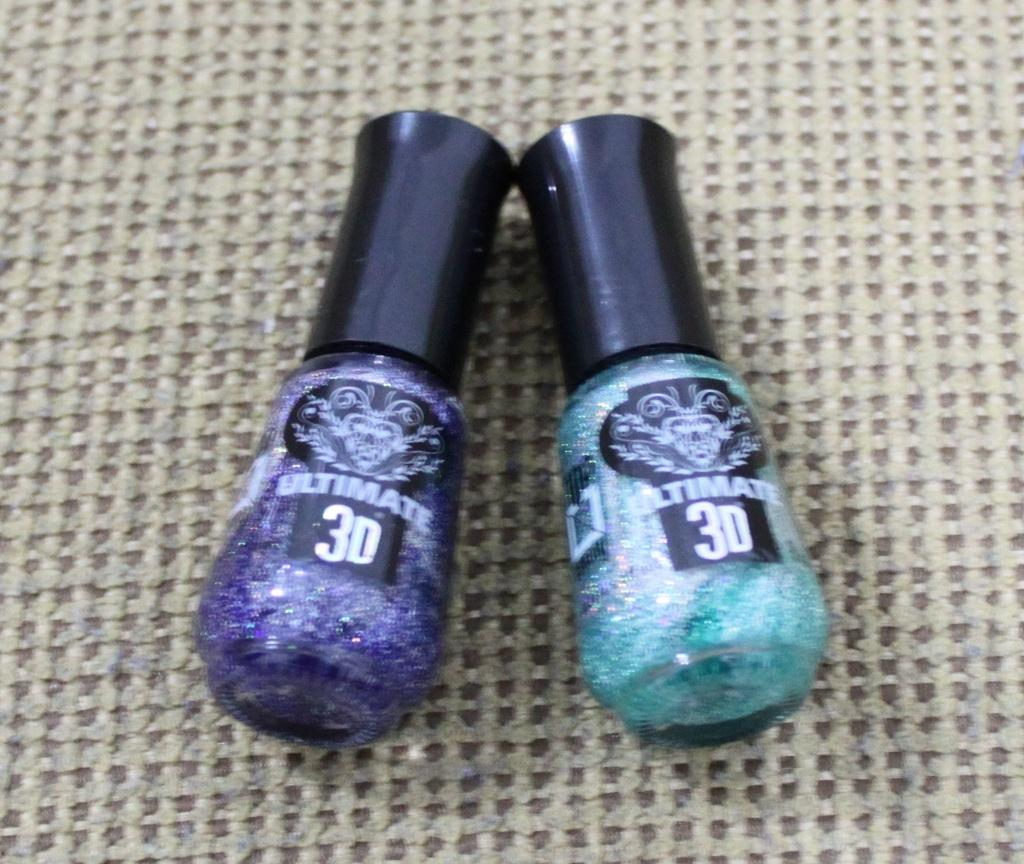What type of product is visible in the image? There is a pair of nail polish in the image. Where is the nail polish placed? The nail polish is placed on a cloth. How many cows are sitting on the chairs in the image? There are no cows or chairs present in the image. What type of spark can be seen coming from the nail polish in the image? There is no spark present in the image; the nail polish is stationary on the cloth. 